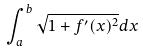Convert formula to latex. <formula><loc_0><loc_0><loc_500><loc_500>\int _ { a } ^ { b } \sqrt { 1 + f ^ { \prime } ( x ) ^ { 2 } } d x</formula> 